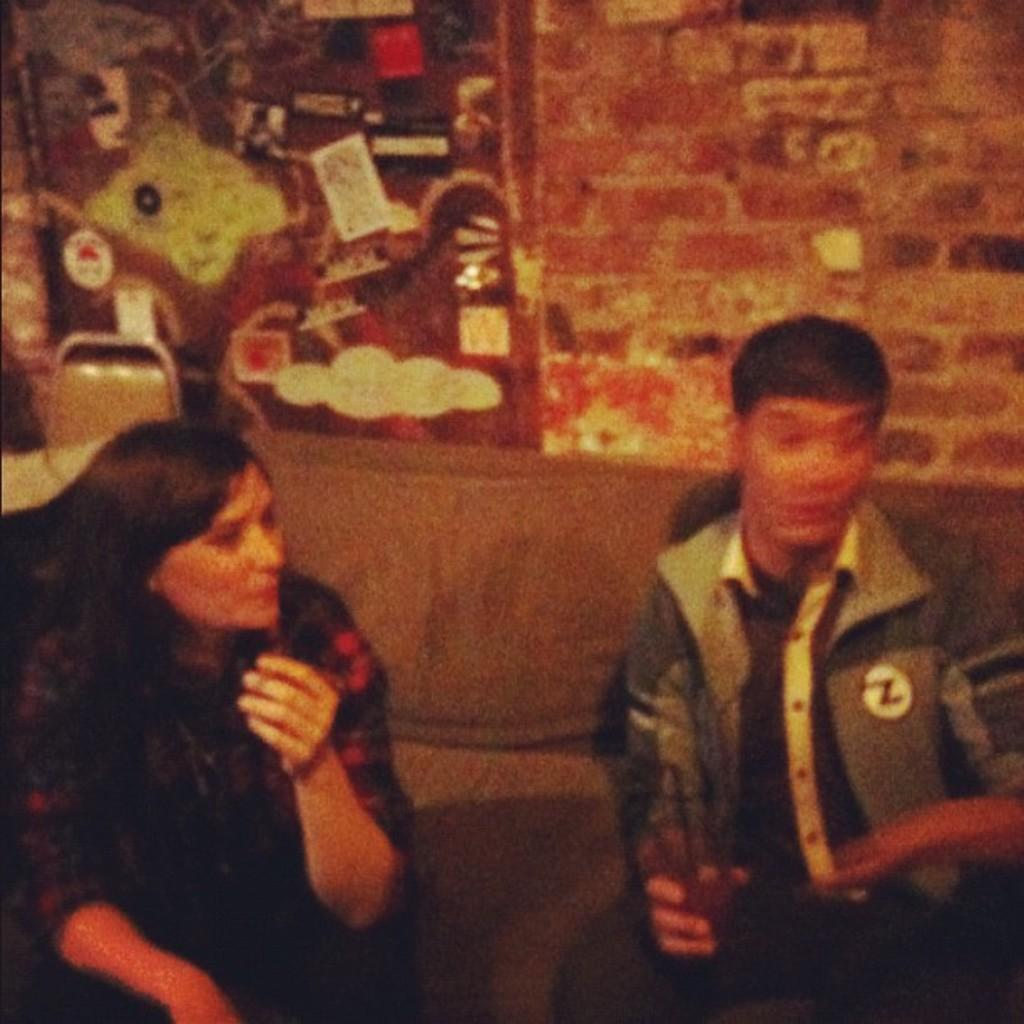How many people are in the image? There are two persons in the image. What are the two persons doing in the image? The two persons are sitting on a sofa set. What can be seen behind the sofa set in the image? There is a wall visible in the image. What type of cough can be heard from the person on the left side of the image? There is no indication of any cough or sound in the image, as it is a still photograph. 